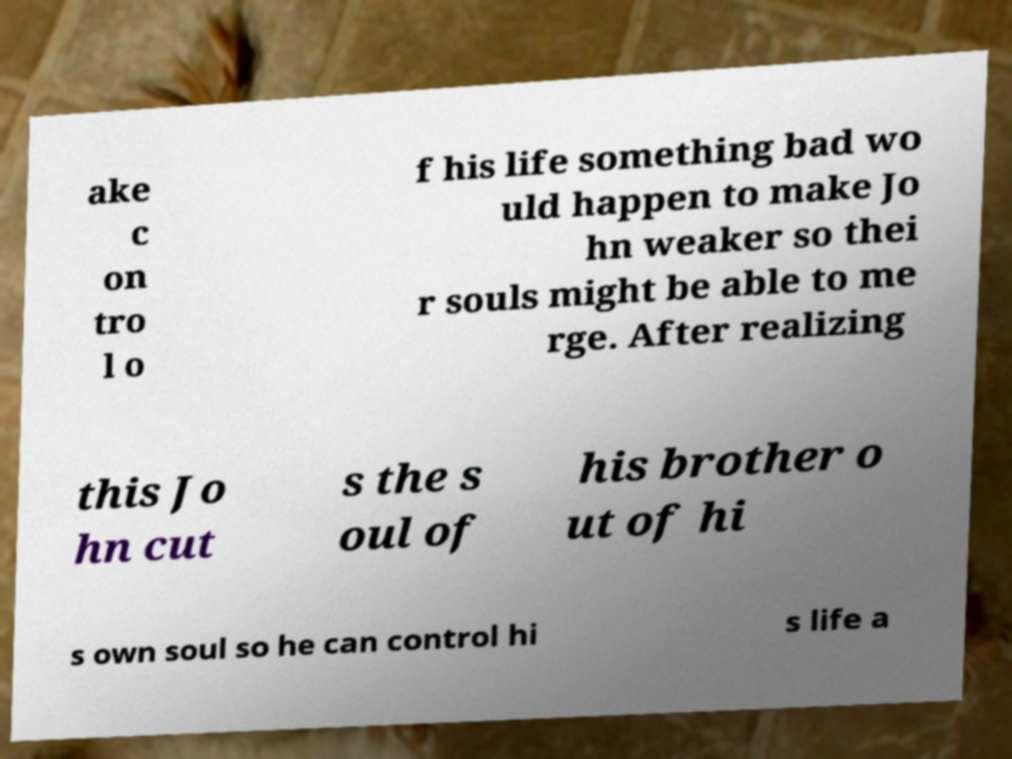I need the written content from this picture converted into text. Can you do that? ake c on tro l o f his life something bad wo uld happen to make Jo hn weaker so thei r souls might be able to me rge. After realizing this Jo hn cut s the s oul of his brother o ut of hi s own soul so he can control hi s life a 